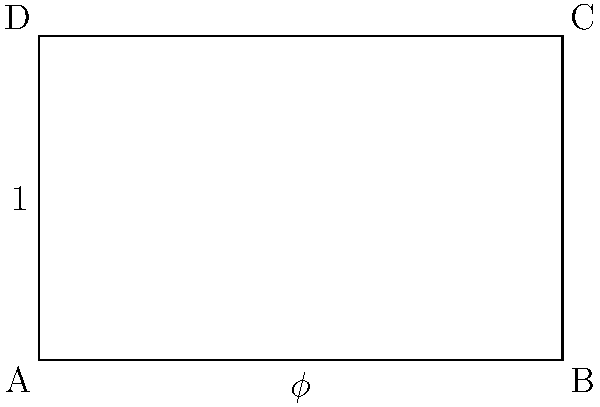In magazine layout design, the golden ratio ($\phi$) is often used to create aesthetically pleasing compositions. Given the golden rectangle ABCD shown above, where the ratio of the longer side to the shorter side is $\phi$, calculate the exact value of $\phi$ to three decimal places. To find the value of $\phi$ (the golden ratio), we can follow these steps:

1) The golden ratio is defined by the equation: $\phi = 1 + \frac{1}{\phi}$

2) Multiply both sides by $\phi$:
   $\phi^2 = \phi + 1$

3) Rearrange to standard quadratic form:
   $\phi^2 - \phi - 1 = 0$

4) Use the quadratic formula: $\phi = \frac{-b \pm \sqrt{b^2 - 4ac}}{2a}$
   Where $a=1$, $b=-1$, and $c=-1$

5) Substitute these values:
   $\phi = \frac{1 \pm \sqrt{1 - 4(1)(-1)}}{2(1)} = \frac{1 \pm \sqrt{5}}{2}$

6) We take the positive root as $\phi$ is a positive ratio:
   $\phi = \frac{1 + \sqrt{5}}{2}$

7) Calculate this value:
   $\phi = \frac{1 + 2.236067977}{2} = 1.618033989$

8) Rounded to three decimal places:
   $\phi \approx 1.618$

This ratio, when applied to magazine layouts, is believed to create a sense of balance and aesthetic appeal that is naturally pleasing to the human eye.
Answer: 1.618 